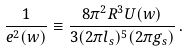<formula> <loc_0><loc_0><loc_500><loc_500>\frac { 1 } { e ^ { 2 } ( w ) } \equiv \frac { 8 \pi ^ { 2 } R ^ { 3 } U ( w ) } { 3 ( 2 \pi l _ { s } ) ^ { 5 } ( 2 \pi g _ { s } ) } \, .</formula> 